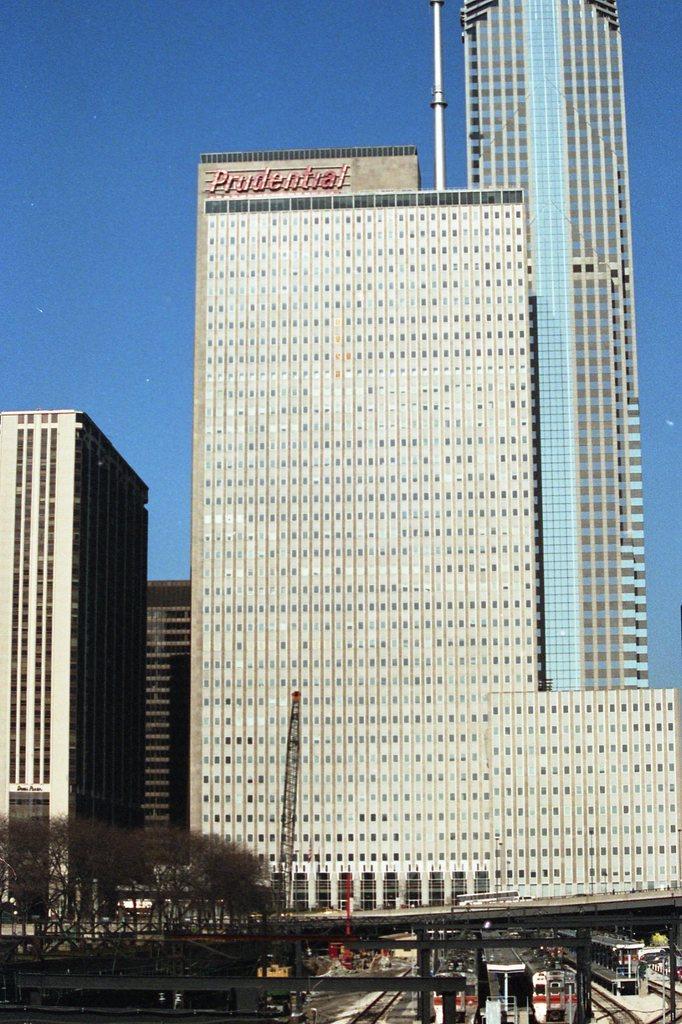Please provide a concise description of this image. In this image, I can see the skyscraper and the buildings. These are the trees. This looks like a tower crane. At the bottoms of the image, I think these are the trains on the rail track. 